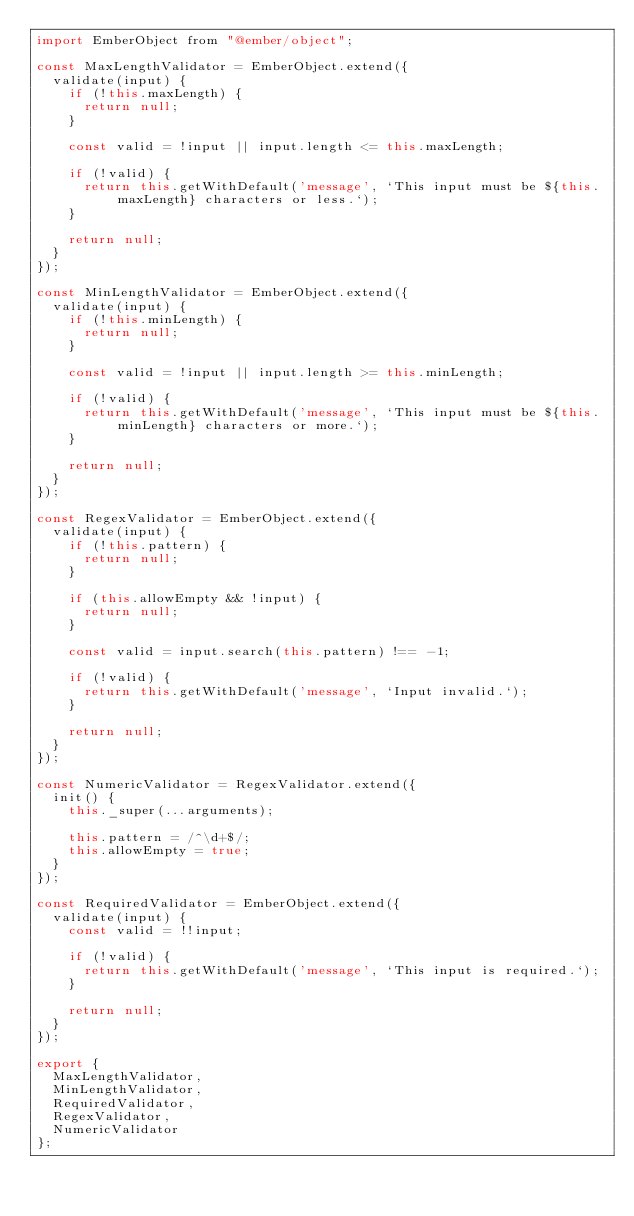<code> <loc_0><loc_0><loc_500><loc_500><_JavaScript_>import EmberObject from "@ember/object";

const MaxLengthValidator = EmberObject.extend({
  validate(input) {
    if (!this.maxLength) {
      return null;
    }

    const valid = !input || input.length <= this.maxLength;

    if (!valid) {
      return this.getWithDefault('message', `This input must be ${this.maxLength} characters or less.`);
    }

    return null;
  }
});

const MinLengthValidator = EmberObject.extend({
  validate(input) {
    if (!this.minLength) {
      return null;
    }

    const valid = !input || input.length >= this.minLength;

    if (!valid) {
      return this.getWithDefault('message', `This input must be ${this.minLength} characters or more.`);
    }

    return null;
  }
});

const RegexValidator = EmberObject.extend({
  validate(input) {
    if (!this.pattern) {
      return null;
    }

    if (this.allowEmpty && !input) {
      return null;
    }

    const valid = input.search(this.pattern) !== -1;

    if (!valid) {
      return this.getWithDefault('message', `Input invalid.`);
    }

    return null;
  }
});

const NumericValidator = RegexValidator.extend({
  init() {
    this._super(...arguments);

    this.pattern = /^\d+$/;
    this.allowEmpty = true;
  }
});

const RequiredValidator = EmberObject.extend({
  validate(input) {
    const valid = !!input;

    if (!valid) {
      return this.getWithDefault('message', `This input is required.`);
    }

    return null;
  }
});

export {
  MaxLengthValidator,
  MinLengthValidator,
  RequiredValidator,
  RegexValidator,
  NumericValidator
};
</code> 